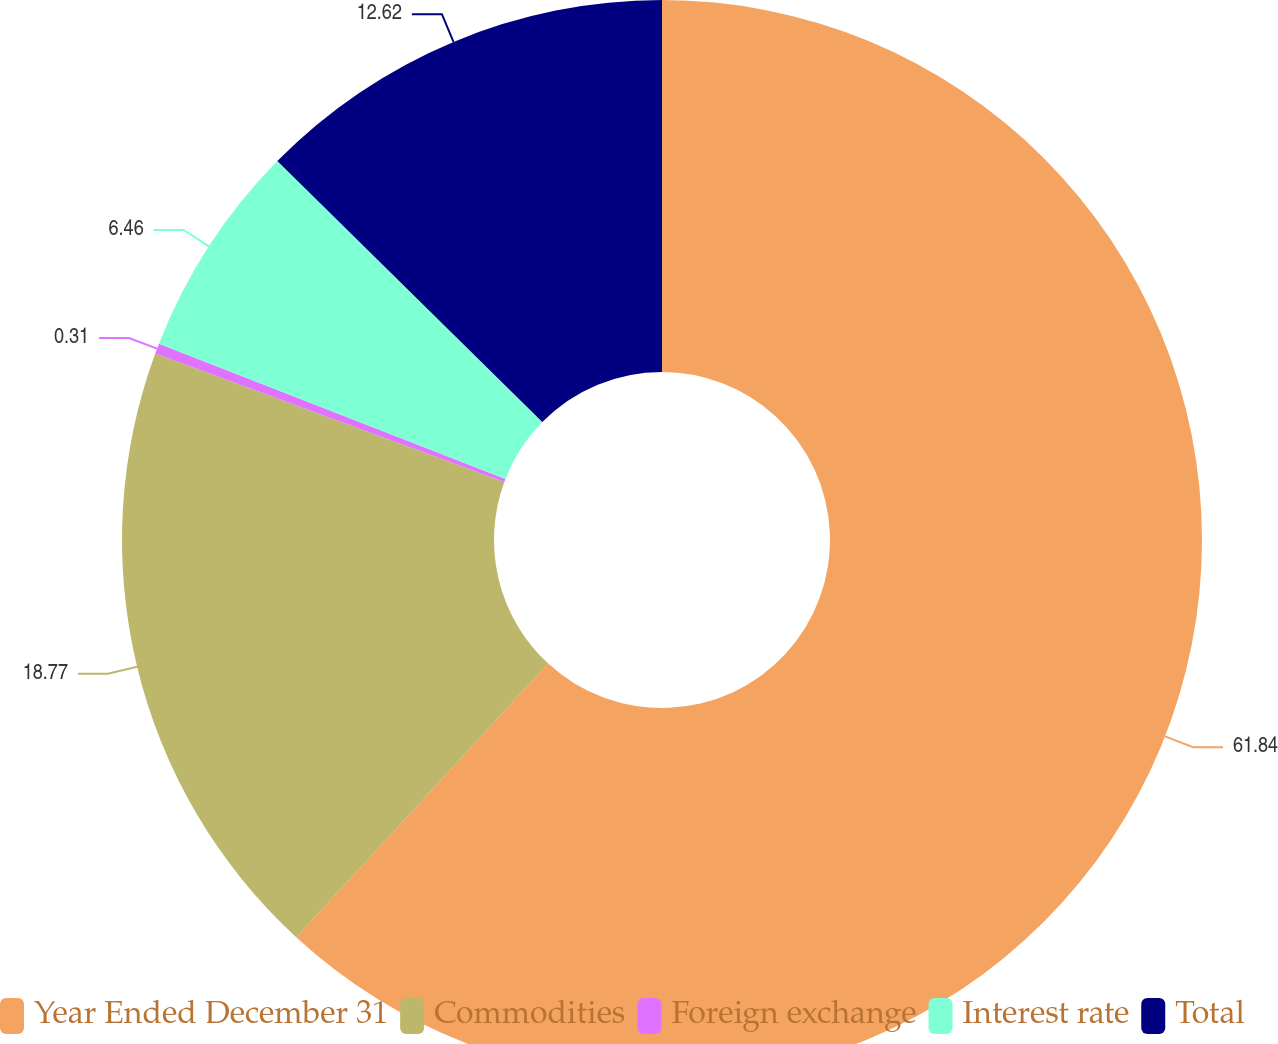<chart> <loc_0><loc_0><loc_500><loc_500><pie_chart><fcel>Year Ended December 31<fcel>Commodities<fcel>Foreign exchange<fcel>Interest rate<fcel>Total<nl><fcel>61.85%<fcel>18.77%<fcel>0.31%<fcel>6.46%<fcel>12.62%<nl></chart> 